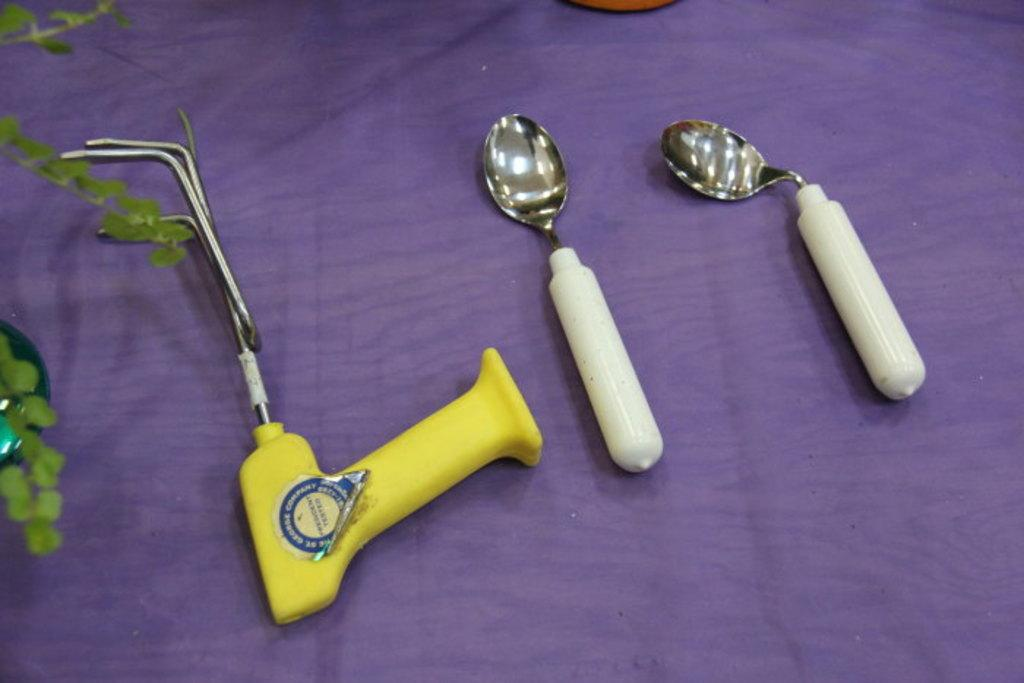How many spoons are visible in the image? There are two spoons in the image. What other utensil or tool can be seen in the image? There is a stirrer in the image. What is located at the bottom of the image? There is a cloth at the bottom of the image. What type of living organism is present in the image? There is a plant in the image. How many clocks are hanging on the wall in the image? There are no clocks visible in the image. Can you describe the flock of deer in the image? There are no deer present in the image. 